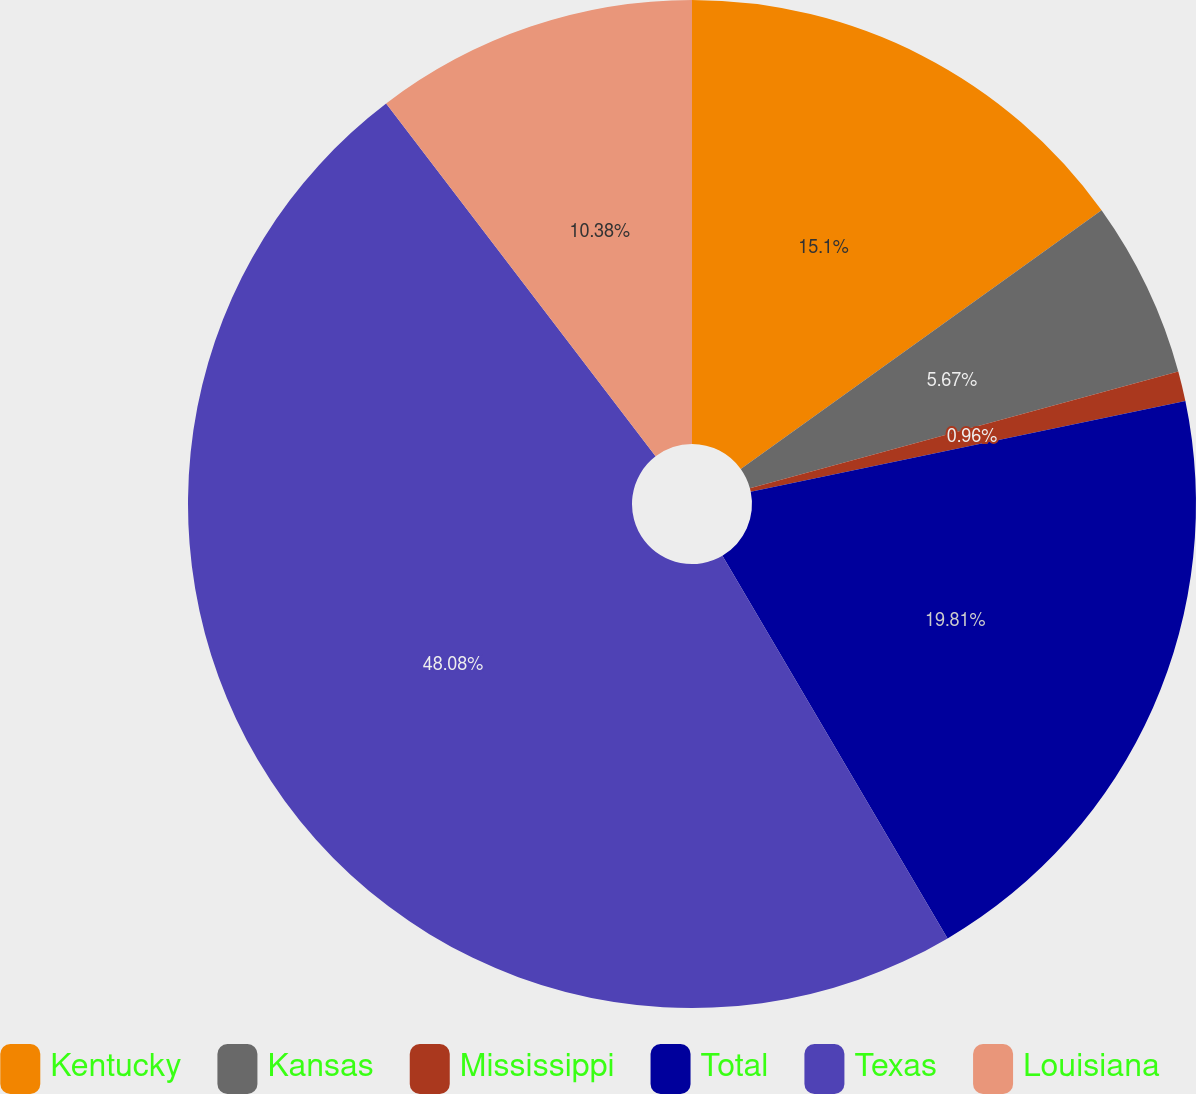<chart> <loc_0><loc_0><loc_500><loc_500><pie_chart><fcel>Kentucky<fcel>Kansas<fcel>Mississippi<fcel>Total<fcel>Texas<fcel>Louisiana<nl><fcel>15.1%<fcel>5.67%<fcel>0.96%<fcel>19.81%<fcel>48.09%<fcel>10.38%<nl></chart> 